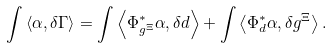Convert formula to latex. <formula><loc_0><loc_0><loc_500><loc_500>\int \left \langle \alpha , \delta \Gamma \right \rangle = \int \left \langle \Phi _ { g ^ { \Xi } } ^ { \ast } \alpha , \delta d \right \rangle + \int \left \langle \Phi _ { d } ^ { \ast } \alpha , \delta g ^ { \Xi } \right \rangle .</formula> 